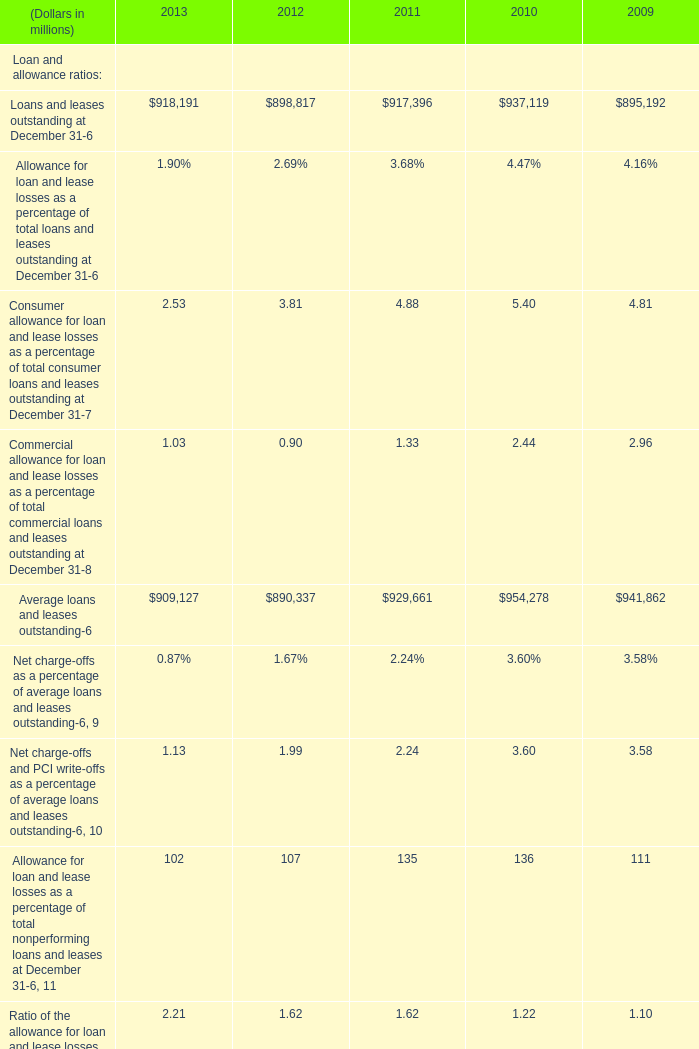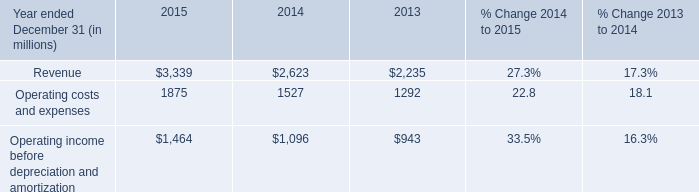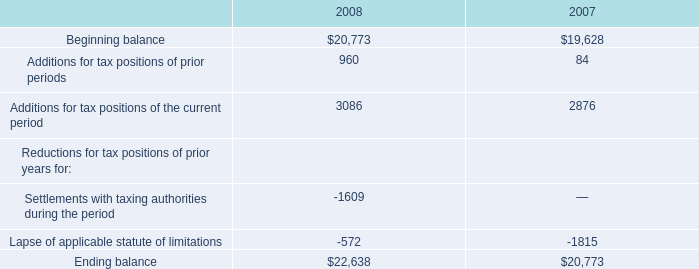In which year is Loans and leases outstanding positive? 
Answer: 2009,2010,2011,2012,0000. 